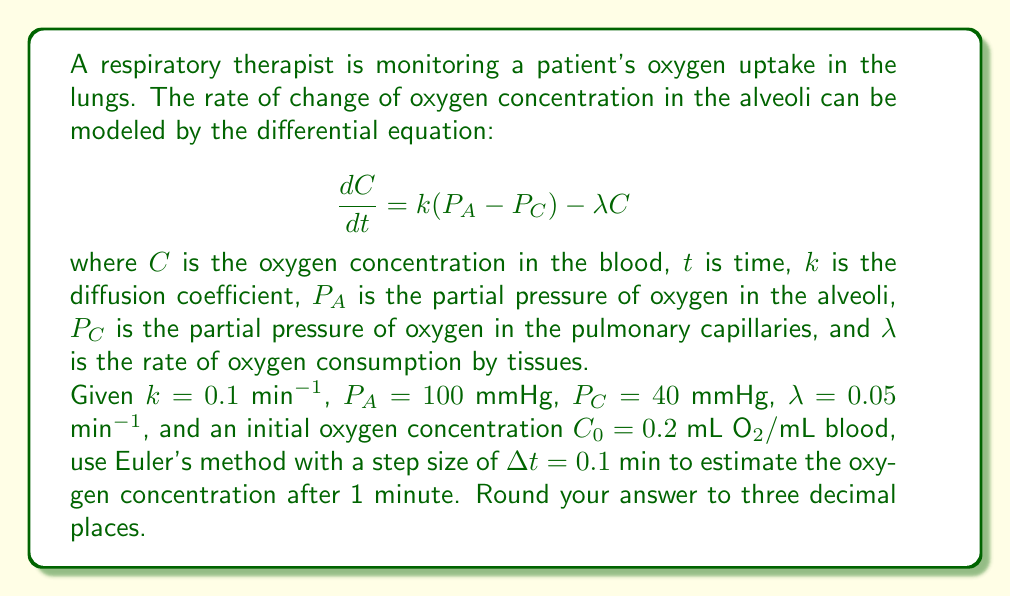Teach me how to tackle this problem. To solve this problem, we'll use Euler's method to numerically approximate the solution to the differential equation. Euler's method is given by:

$$C_{n+1} = C_n + \Delta t \cdot f(t_n, C_n)$$

where $f(t, C) = \frac{dC}{dt} = k(P_A - P_C) - \lambda C$

Step 1: Set up the initial conditions and parameters
- $C_0 = 0.2$ mL O₂/mL blood
- $\Delta t = 0.1$ min
- $t_{final} = 1$ min
- Number of steps = $t_{final} / \Delta t = 1 / 0.1 = 10$ steps

Step 2: Implement Euler's method
For each step, we'll calculate:
$$C_{n+1} = C_n + \Delta t \cdot [k(P_A - P_C) - \lambda C_n]$$

Let's perform the first few iterations:

n = 0:
$C_1 = 0.2 + 0.1 \cdot [0.1(100 - 40) - 0.05 \cdot 0.2] = 0.2 + 0.1 \cdot (6 - 0.01) = 0.2599$

n = 1:
$C_2 = 0.2599 + 0.1 \cdot [0.1(100 - 40) - 0.05 \cdot 0.2599] = 0.2599 + 0.1 \cdot (6 - 0.012995) = 0.3186$

We continue this process for the remaining steps until we reach n = 9 (10 steps total).

Step 3: Complete all iterations
After completing all 10 iterations, we arrive at the final concentration.

Step 4: Round the result to three decimal places
The final concentration after 1 minute is rounded to three decimal places.
Answer: $C(1) \approx 0.735$ mL O₂/mL blood 